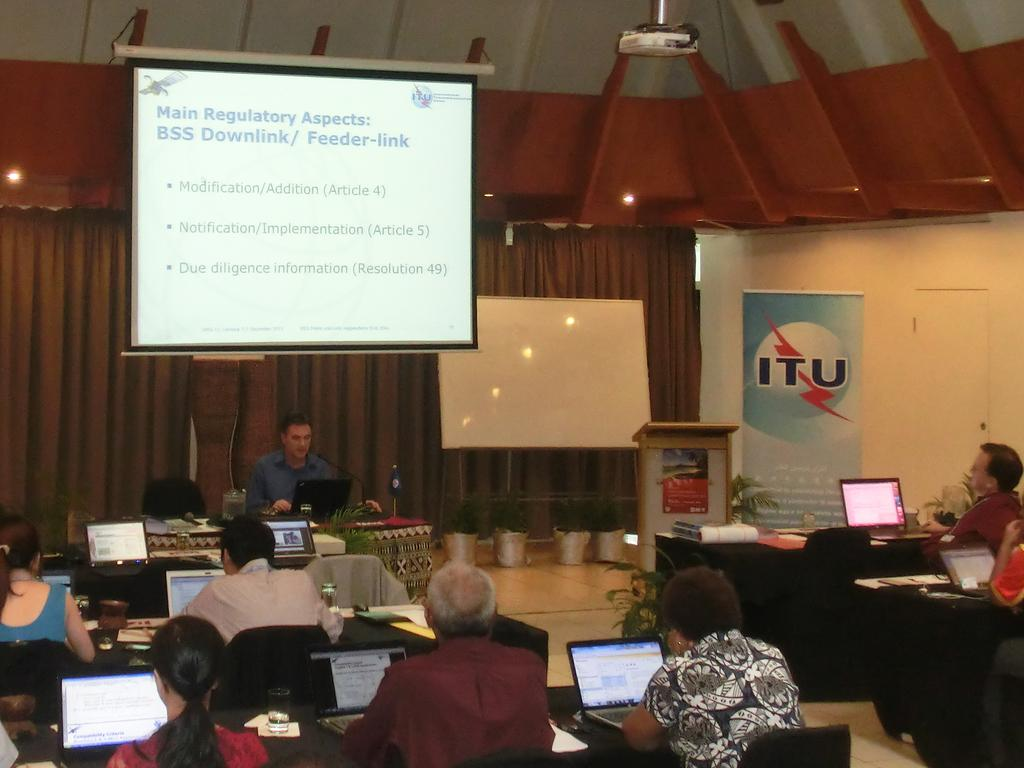<image>
Render a clear and concise summary of the photo. ITU is holding a conference in front of a group of people with laptops. 